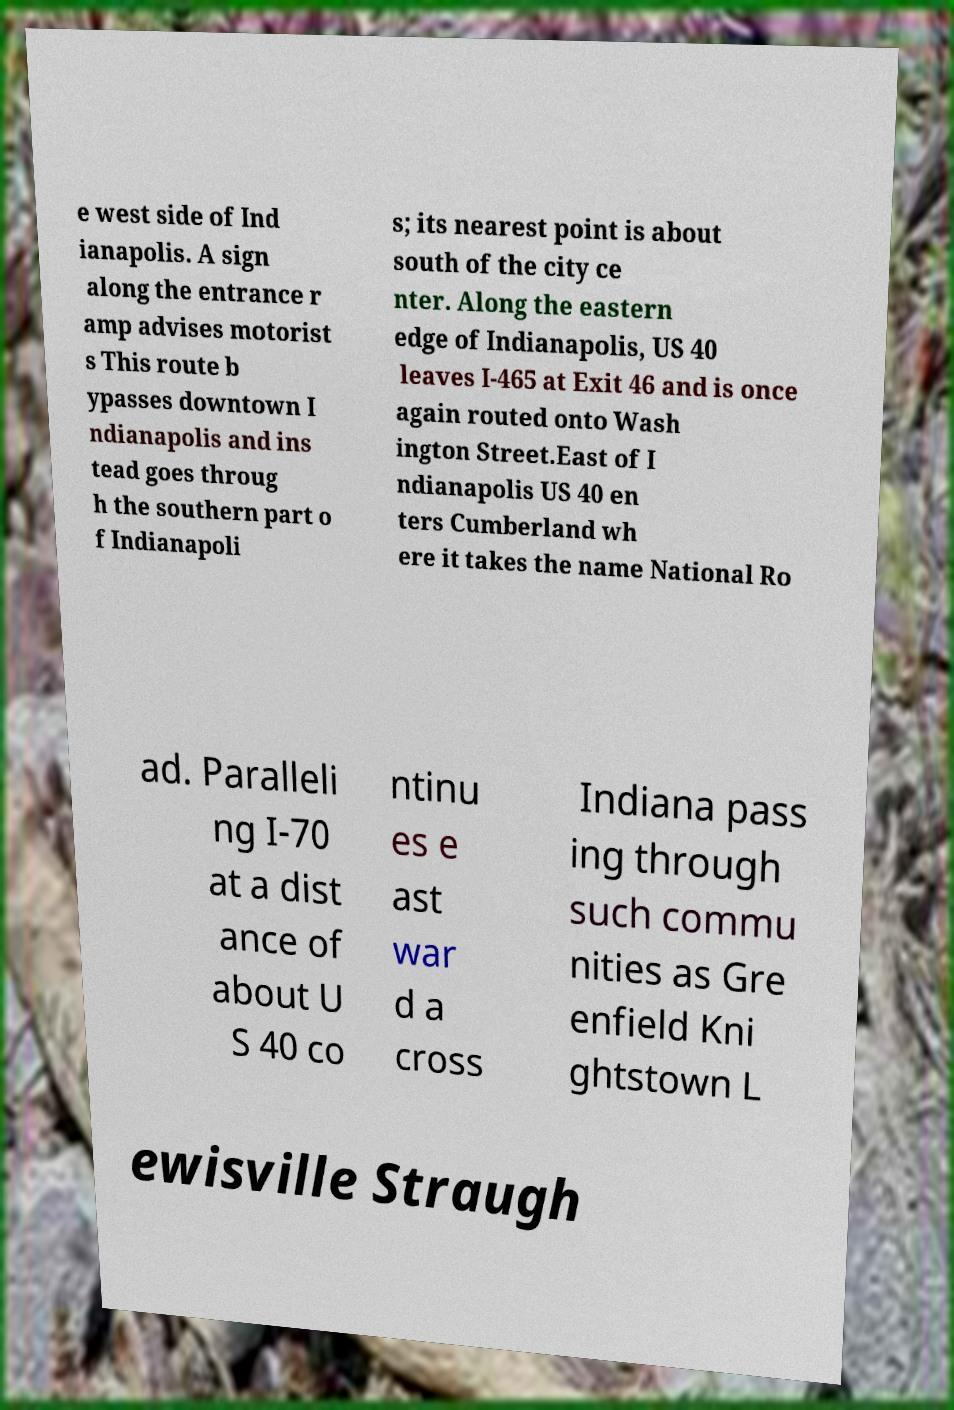Could you assist in decoding the text presented in this image and type it out clearly? e west side of Ind ianapolis. A sign along the entrance r amp advises motorist s This route b ypasses downtown I ndianapolis and ins tead goes throug h the southern part o f Indianapoli s; its nearest point is about south of the city ce nter. Along the eastern edge of Indianapolis, US 40 leaves I-465 at Exit 46 and is once again routed onto Wash ington Street.East of I ndianapolis US 40 en ters Cumberland wh ere it takes the name National Ro ad. Paralleli ng I-70 at a dist ance of about U S 40 co ntinu es e ast war d a cross Indiana pass ing through such commu nities as Gre enfield Kni ghtstown L ewisville Straugh 